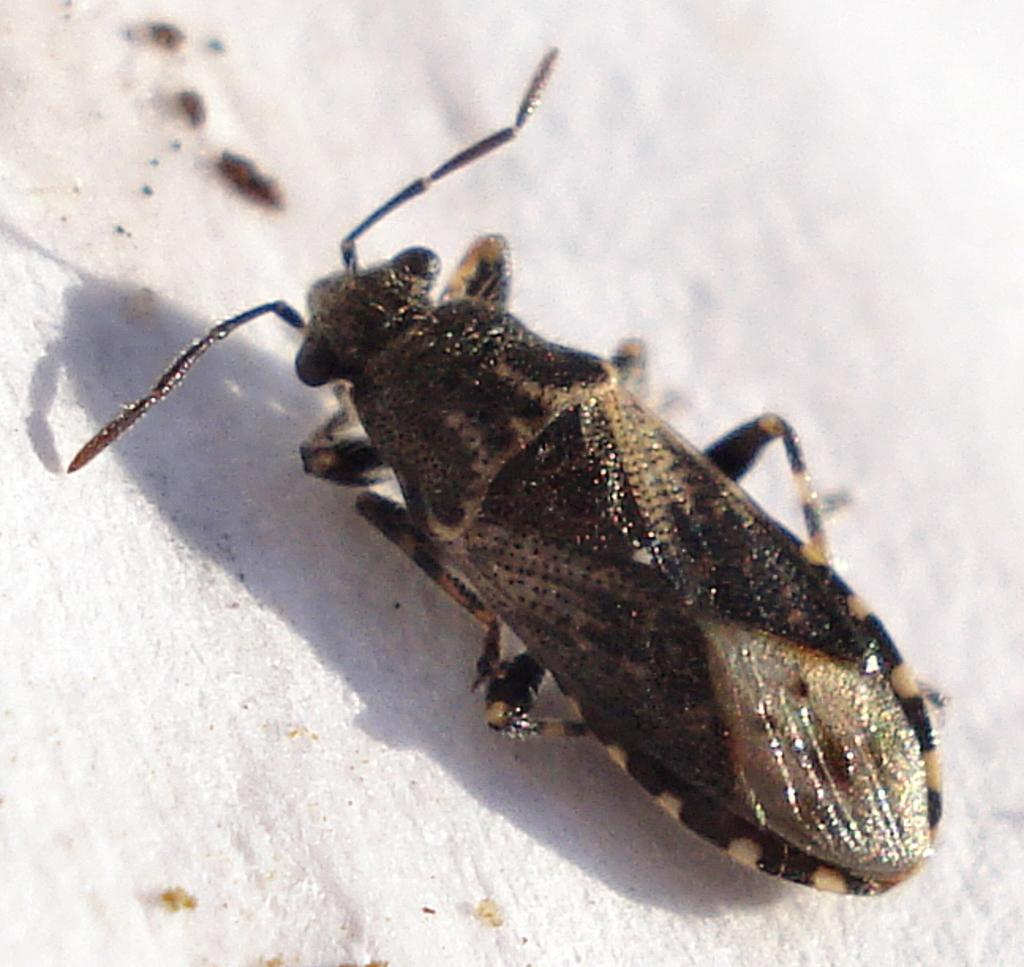What type of creature can be seen in the image? There is an insect in the image. Where is the insect located in the image? The insect is laying on the floor. What type of soap is the insect using to clean itself in the image? There is no soap present in the image, and insects do not use soap to clean themselves. 